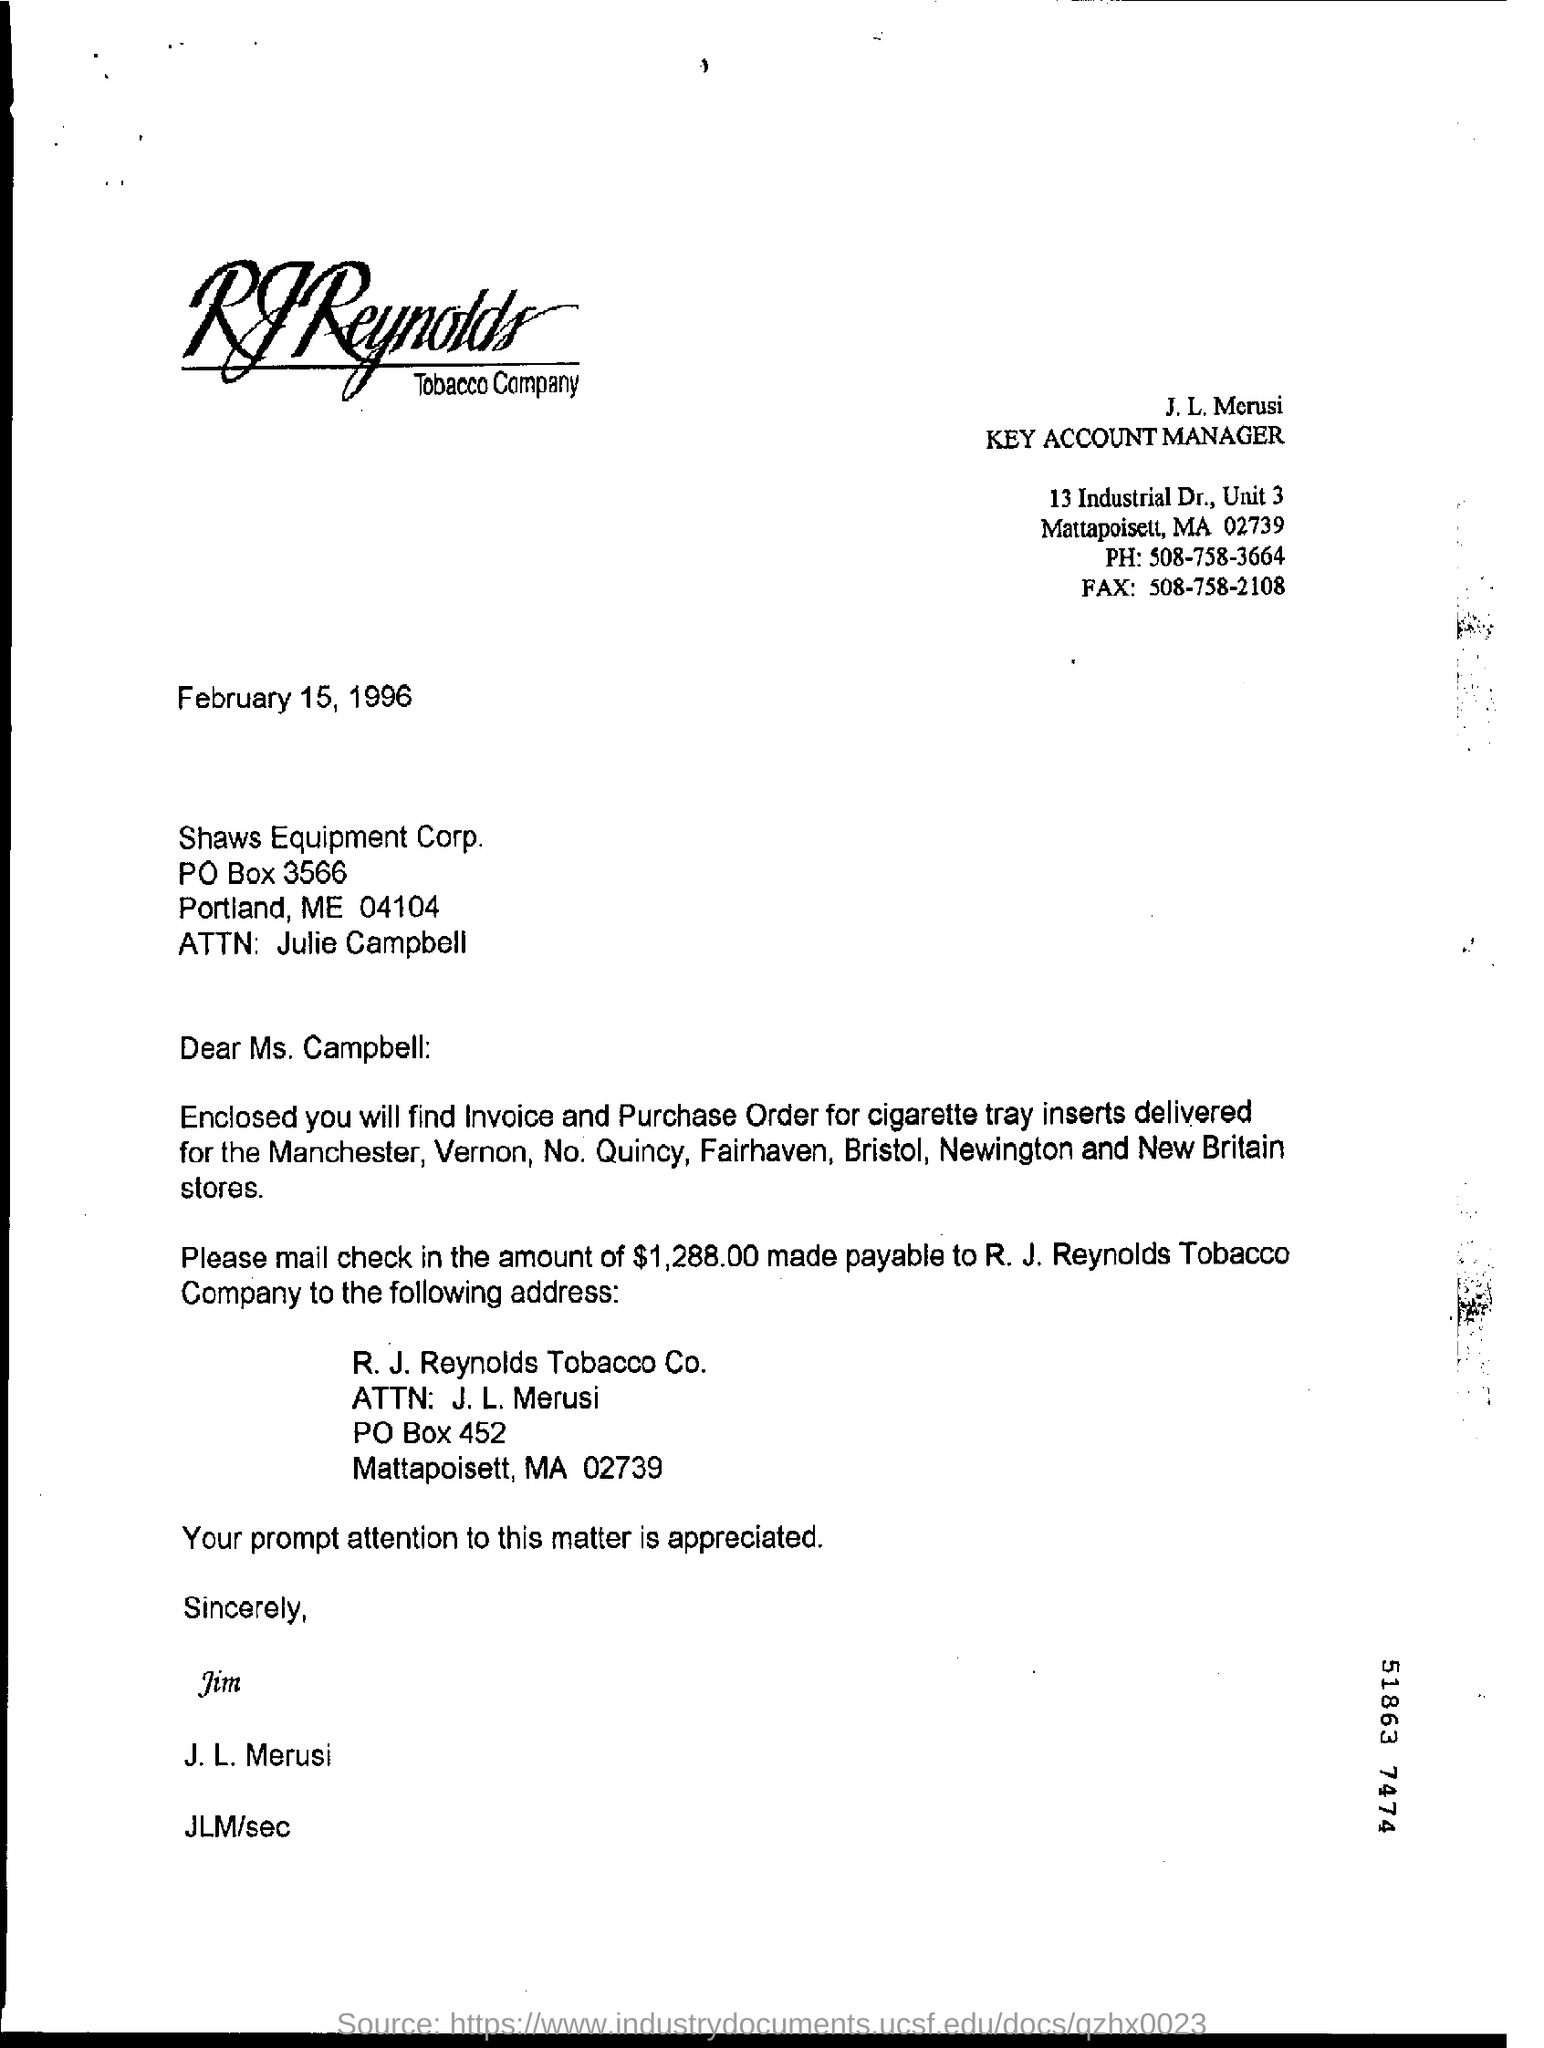What is the fax number in the letter?
Provide a succinct answer. 508-758-2108. 